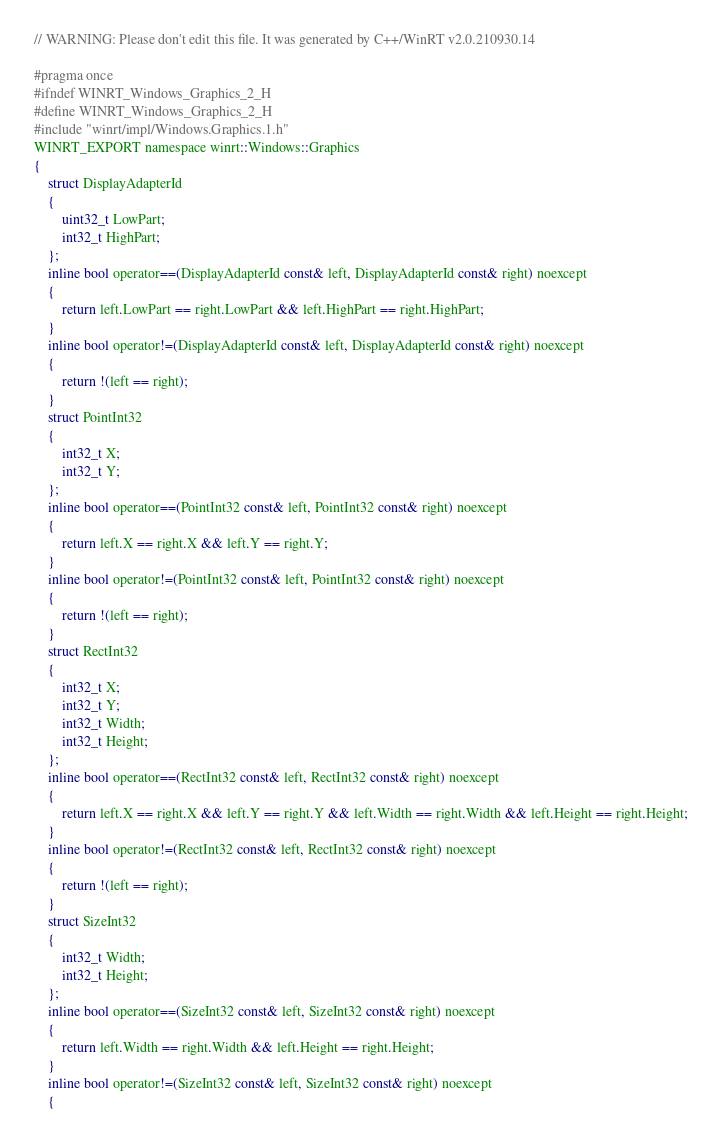Convert code to text. <code><loc_0><loc_0><loc_500><loc_500><_C_>// WARNING: Please don't edit this file. It was generated by C++/WinRT v2.0.210930.14

#pragma once
#ifndef WINRT_Windows_Graphics_2_H
#define WINRT_Windows_Graphics_2_H
#include "winrt/impl/Windows.Graphics.1.h"
WINRT_EXPORT namespace winrt::Windows::Graphics
{
    struct DisplayAdapterId
    {
        uint32_t LowPart;
        int32_t HighPart;
    };
    inline bool operator==(DisplayAdapterId const& left, DisplayAdapterId const& right) noexcept
    {
        return left.LowPart == right.LowPart && left.HighPart == right.HighPart;
    }
    inline bool operator!=(DisplayAdapterId const& left, DisplayAdapterId const& right) noexcept
    {
        return !(left == right);
    }
    struct PointInt32
    {
        int32_t X;
        int32_t Y;
    };
    inline bool operator==(PointInt32 const& left, PointInt32 const& right) noexcept
    {
        return left.X == right.X && left.Y == right.Y;
    }
    inline bool operator!=(PointInt32 const& left, PointInt32 const& right) noexcept
    {
        return !(left == right);
    }
    struct RectInt32
    {
        int32_t X;
        int32_t Y;
        int32_t Width;
        int32_t Height;
    };
    inline bool operator==(RectInt32 const& left, RectInt32 const& right) noexcept
    {
        return left.X == right.X && left.Y == right.Y && left.Width == right.Width && left.Height == right.Height;
    }
    inline bool operator!=(RectInt32 const& left, RectInt32 const& right) noexcept
    {
        return !(left == right);
    }
    struct SizeInt32
    {
        int32_t Width;
        int32_t Height;
    };
    inline bool operator==(SizeInt32 const& left, SizeInt32 const& right) noexcept
    {
        return left.Width == right.Width && left.Height == right.Height;
    }
    inline bool operator!=(SizeInt32 const& left, SizeInt32 const& right) noexcept
    {</code> 